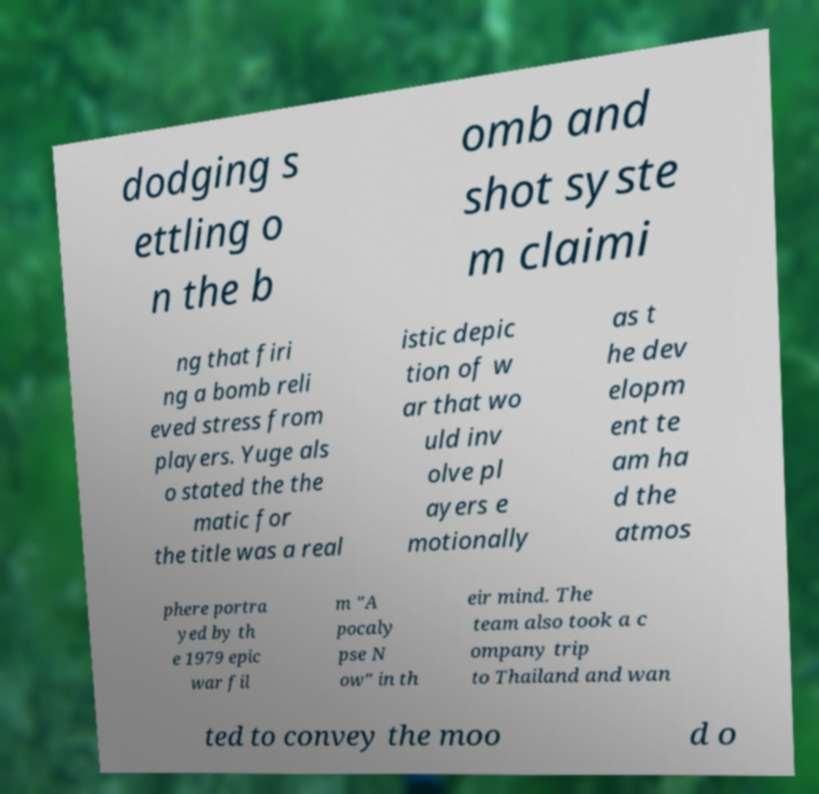For documentation purposes, I need the text within this image transcribed. Could you provide that? dodging s ettling o n the b omb and shot syste m claimi ng that firi ng a bomb reli eved stress from players. Yuge als o stated the the matic for the title was a real istic depic tion of w ar that wo uld inv olve pl ayers e motionally as t he dev elopm ent te am ha d the atmos phere portra yed by th e 1979 epic war fil m "A pocaly pse N ow" in th eir mind. The team also took a c ompany trip to Thailand and wan ted to convey the moo d o 